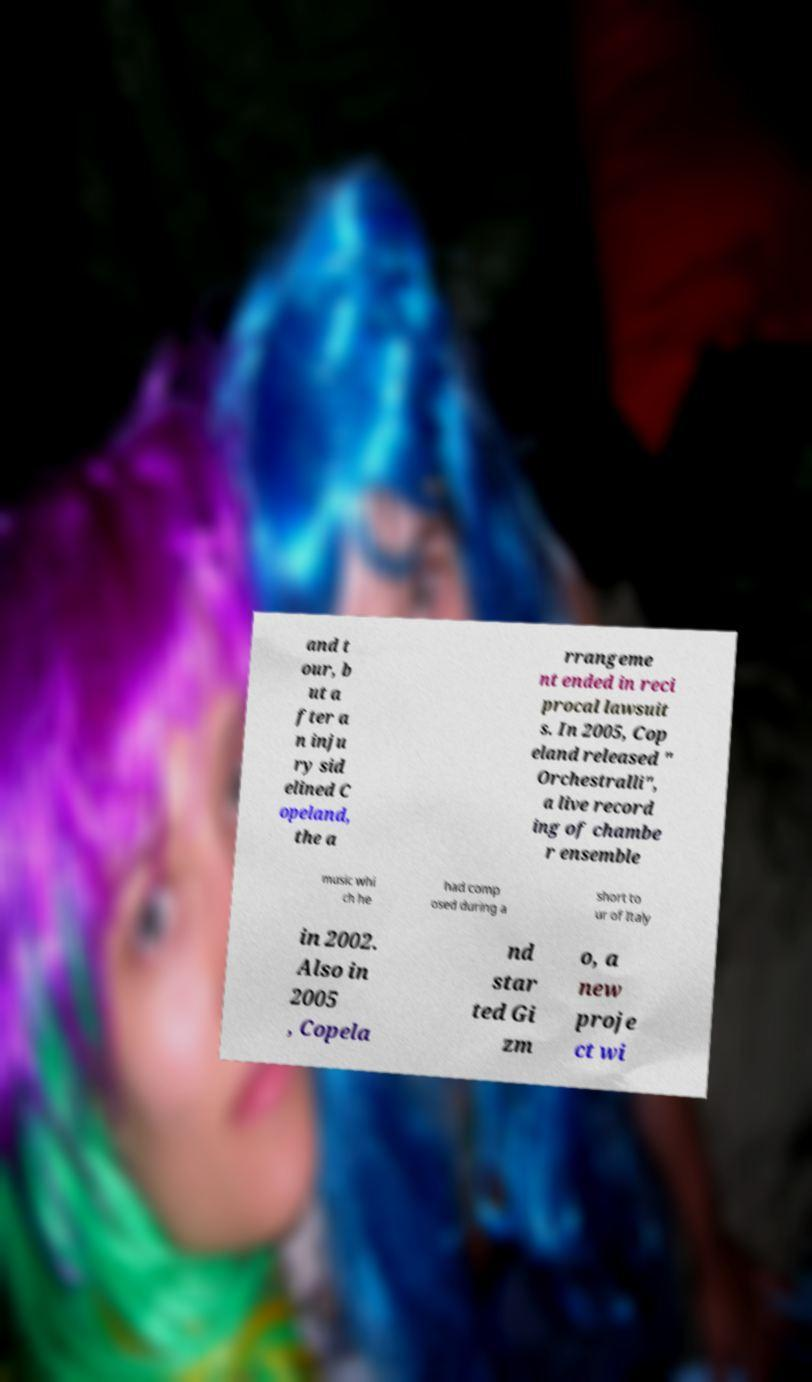Can you accurately transcribe the text from the provided image for me? and t our, b ut a fter a n inju ry sid elined C opeland, the a rrangeme nt ended in reci procal lawsuit s. In 2005, Cop eland released " Orchestralli", a live record ing of chambe r ensemble music whi ch he had comp osed during a short to ur of Italy in 2002. Also in 2005 , Copela nd star ted Gi zm o, a new proje ct wi 